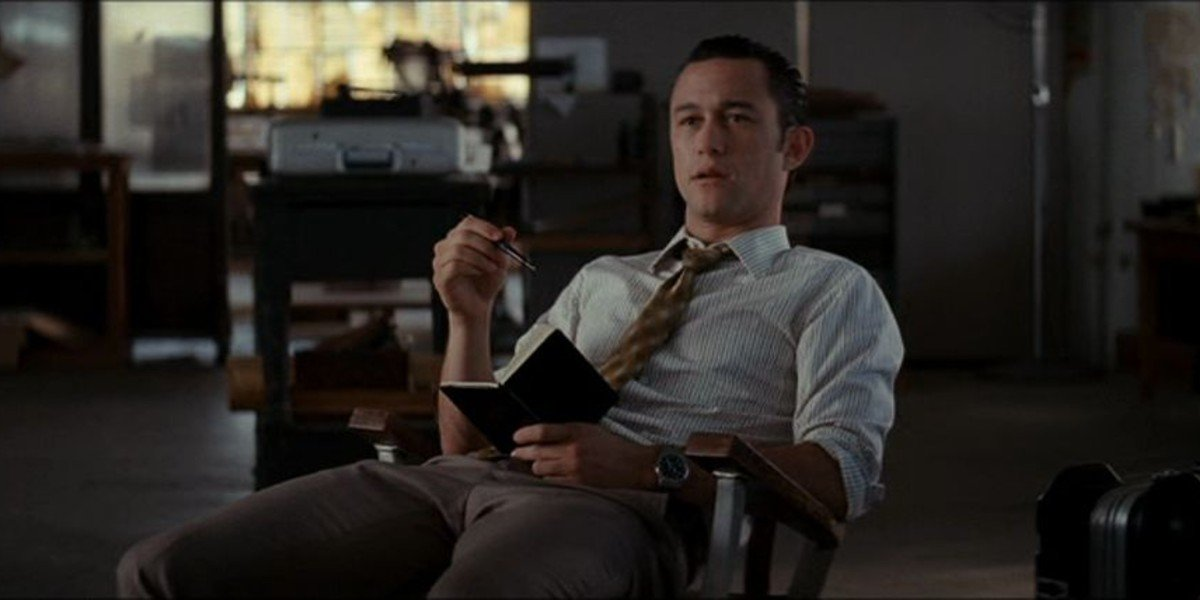How does the lighting in the room enhance the mood of the scene? The lighting in the room, primarily coming through the window, creates a warm yet focused ambiance. It highlights the man’s thoughtful expression and professional attire, casting gentle shadows that add depth to the scene. This lighting helps to convey a mood of contemplation and introspection, emphasizing the importance of the moment as he delves into his thoughts. 